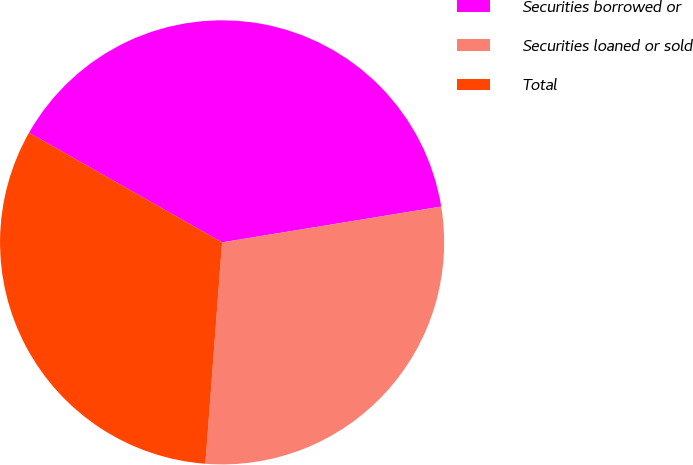Convert chart. <chart><loc_0><loc_0><loc_500><loc_500><pie_chart><fcel>Securities borrowed or<fcel>Securities loaned or sold<fcel>Total<nl><fcel>39.21%<fcel>28.78%<fcel>32.02%<nl></chart> 